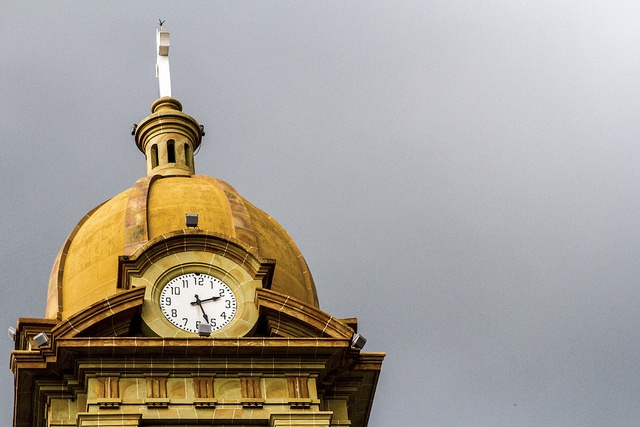Describe the objects in this image and their specific colors. I can see a clock in darkgray, white, gray, and black tones in this image. 